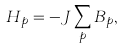<formula> <loc_0><loc_0><loc_500><loc_500>H _ { p } = - J \sum _ { p } B _ { p } ,</formula> 